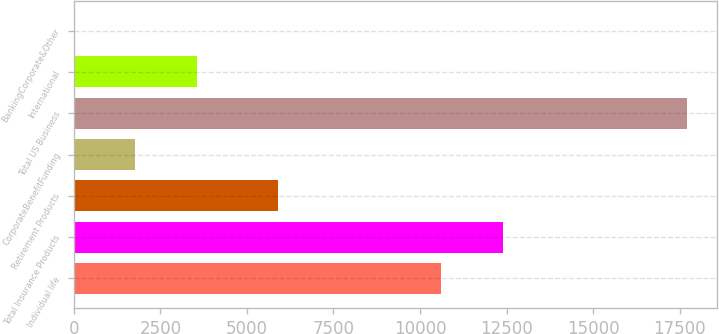Convert chart. <chart><loc_0><loc_0><loc_500><loc_500><bar_chart><fcel>Individual life<fcel>Total Insurance Products<fcel>Retirement Products<fcel>CorporateBenefitFunding<fcel>Total US Business<fcel>International<fcel>BankingCorporate&Other<nl><fcel>10617<fcel>12386.4<fcel>5888<fcel>1776.4<fcel>17701<fcel>3545.8<fcel>7<nl></chart> 